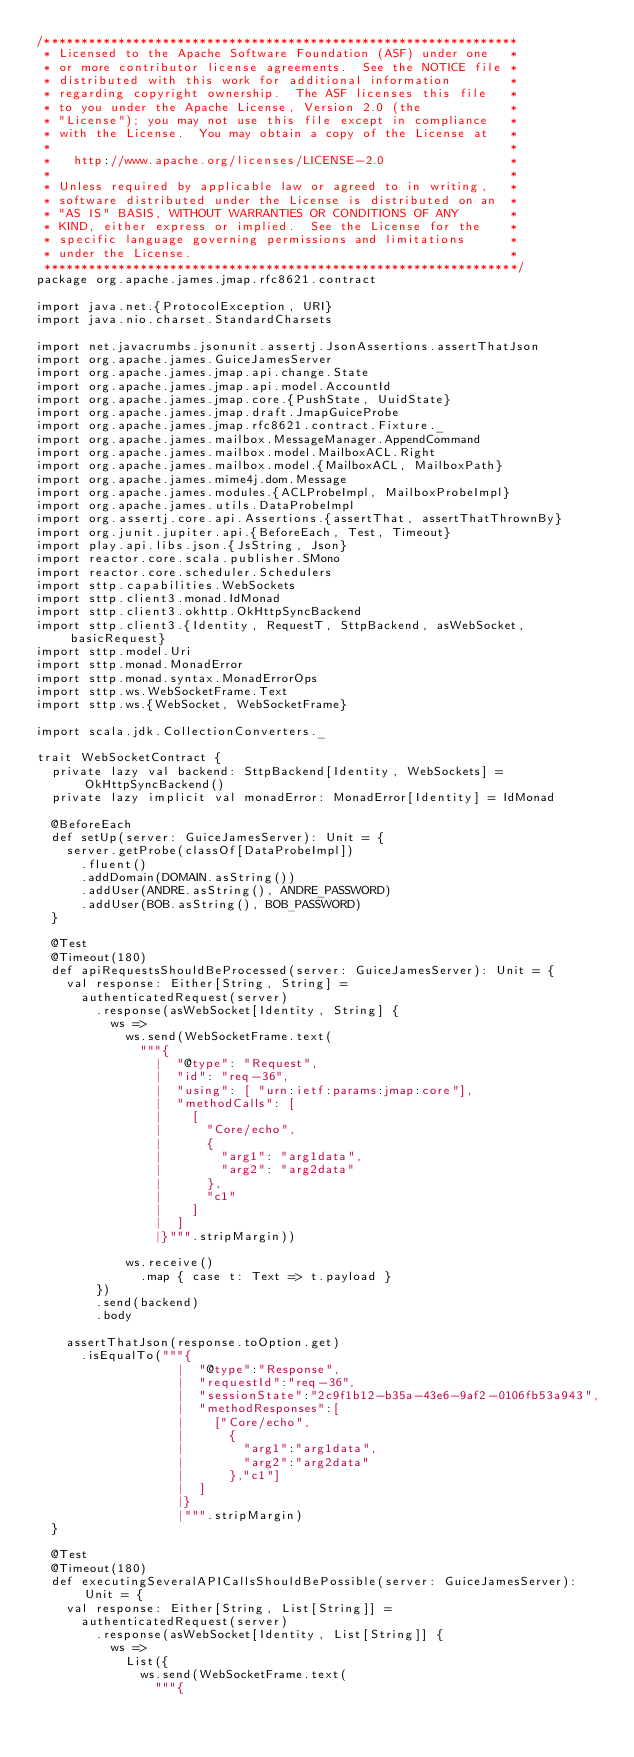Convert code to text. <code><loc_0><loc_0><loc_500><loc_500><_Scala_>/****************************************************************
 * Licensed to the Apache Software Foundation (ASF) under one   *
 * or more contributor license agreements.  See the NOTICE file *
 * distributed with this work for additional information        *
 * regarding copyright ownership.  The ASF licenses this file   *
 * to you under the Apache License, Version 2.0 (the            *
 * "License"); you may not use this file except in compliance   *
 * with the License.  You may obtain a copy of the License at   *
 *                                                              *
 *   http://www.apache.org/licenses/LICENSE-2.0                 *
 *                                                              *
 * Unless required by applicable law or agreed to in writing,   *
 * software distributed under the License is distributed on an  *
 * "AS IS" BASIS, WITHOUT WARRANTIES OR CONDITIONS OF ANY       *
 * KIND, either express or implied.  See the License for the    *
 * specific language governing permissions and limitations      *
 * under the License.                                           *
 ****************************************************************/
package org.apache.james.jmap.rfc8621.contract

import java.net.{ProtocolException, URI}
import java.nio.charset.StandardCharsets

import net.javacrumbs.jsonunit.assertj.JsonAssertions.assertThatJson
import org.apache.james.GuiceJamesServer
import org.apache.james.jmap.api.change.State
import org.apache.james.jmap.api.model.AccountId
import org.apache.james.jmap.core.{PushState, UuidState}
import org.apache.james.jmap.draft.JmapGuiceProbe
import org.apache.james.jmap.rfc8621.contract.Fixture._
import org.apache.james.mailbox.MessageManager.AppendCommand
import org.apache.james.mailbox.model.MailboxACL.Right
import org.apache.james.mailbox.model.{MailboxACL, MailboxPath}
import org.apache.james.mime4j.dom.Message
import org.apache.james.modules.{ACLProbeImpl, MailboxProbeImpl}
import org.apache.james.utils.DataProbeImpl
import org.assertj.core.api.Assertions.{assertThat, assertThatThrownBy}
import org.junit.jupiter.api.{BeforeEach, Test, Timeout}
import play.api.libs.json.{JsString, Json}
import reactor.core.scala.publisher.SMono
import reactor.core.scheduler.Schedulers
import sttp.capabilities.WebSockets
import sttp.client3.monad.IdMonad
import sttp.client3.okhttp.OkHttpSyncBackend
import sttp.client3.{Identity, RequestT, SttpBackend, asWebSocket, basicRequest}
import sttp.model.Uri
import sttp.monad.MonadError
import sttp.monad.syntax.MonadErrorOps
import sttp.ws.WebSocketFrame.Text
import sttp.ws.{WebSocket, WebSocketFrame}

import scala.jdk.CollectionConverters._

trait WebSocketContract {
  private lazy val backend: SttpBackend[Identity, WebSockets] = OkHttpSyncBackend()
  private lazy implicit val monadError: MonadError[Identity] = IdMonad

  @BeforeEach
  def setUp(server: GuiceJamesServer): Unit = {
    server.getProbe(classOf[DataProbeImpl])
      .fluent()
      .addDomain(DOMAIN.asString())
      .addUser(ANDRE.asString(), ANDRE_PASSWORD)
      .addUser(BOB.asString(), BOB_PASSWORD)
  }

  @Test
  @Timeout(180)
  def apiRequestsShouldBeProcessed(server: GuiceJamesServer): Unit = {
    val response: Either[String, String] =
      authenticatedRequest(server)
        .response(asWebSocket[Identity, String] {
          ws =>
            ws.send(WebSocketFrame.text(
              """{
                |  "@type": "Request",
                |  "id": "req-36",
                |  "using": [ "urn:ietf:params:jmap:core"],
                |  "methodCalls": [
                |    [
                |      "Core/echo",
                |      {
                |        "arg1": "arg1data",
                |        "arg2": "arg2data"
                |      },
                |      "c1"
                |    ]
                |  ]
                |}""".stripMargin))

            ws.receive()
              .map { case t: Text => t.payload }
        })
        .send(backend)
        .body

    assertThatJson(response.toOption.get)
      .isEqualTo("""{
                   |  "@type":"Response",
                   |  "requestId":"req-36",
                   |  "sessionState":"2c9f1b12-b35a-43e6-9af2-0106fb53a943",
                   |  "methodResponses":[
                   |    ["Core/echo",
                   |      {
                   |        "arg1":"arg1data",
                   |        "arg2":"arg2data"
                   |      },"c1"]
                   |  ]
                   |}
                   |""".stripMargin)
  }

  @Test
  @Timeout(180)
  def executingSeveralAPICallsShouldBePossible(server: GuiceJamesServer): Unit = {
    val response: Either[String, List[String]] =
      authenticatedRequest(server)
        .response(asWebSocket[Identity, List[String]] {
          ws =>
            List({
              ws.send(WebSocketFrame.text(
                """{</code> 